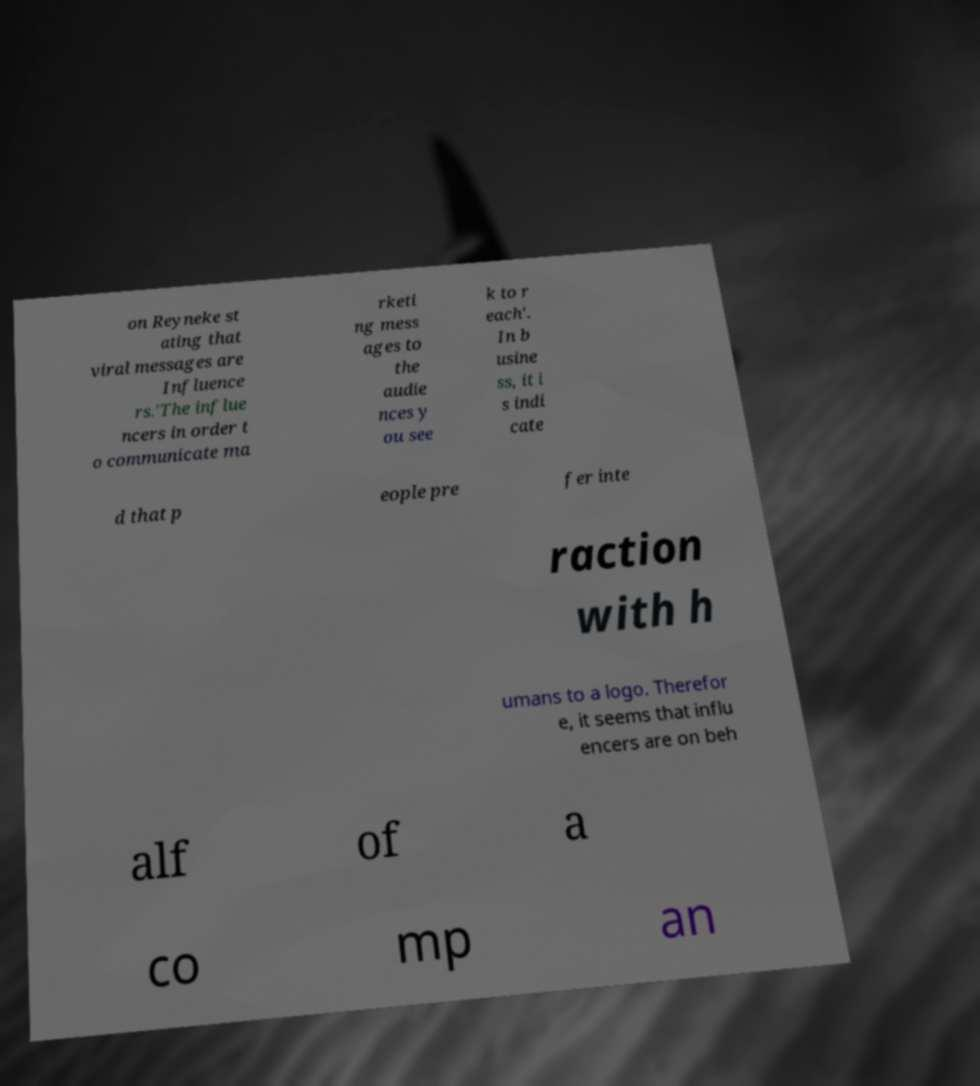Can you read and provide the text displayed in the image?This photo seems to have some interesting text. Can you extract and type it out for me? on Reyneke st ating that viral messages are Influence rs.'The influe ncers in order t o communicate ma rketi ng mess ages to the audie nces y ou see k to r each'. In b usine ss, it i s indi cate d that p eople pre fer inte raction with h umans to a logo. Therefor e, it seems that influ encers are on beh alf of a co mp an 